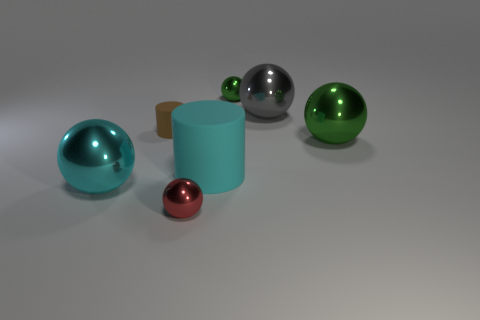What is the size of the metal object that is the same color as the big cylinder?
Give a very brief answer. Large. Do the brown thing and the cyan matte cylinder have the same size?
Make the answer very short. No. What size is the object that is both in front of the big cylinder and to the left of the red object?
Ensure brevity in your answer.  Large. How many shiny things are cyan objects or large things?
Provide a succinct answer. 3. Are there more cyan objects that are to the right of the small red metallic object than large yellow rubber balls?
Make the answer very short. Yes. What is the material of the ball that is left of the red thing?
Offer a terse response. Metal. How many spheres are made of the same material as the large cyan cylinder?
Provide a short and direct response. 0. What shape is the large metal object that is both behind the big cyan sphere and left of the big green metal sphere?
Give a very brief answer. Sphere. How many objects are either things that are on the right side of the small green sphere or metallic objects left of the large cyan rubber cylinder?
Make the answer very short. 4. Are there an equal number of tiny red spheres behind the tiny rubber cylinder and large shiny spheres on the left side of the gray thing?
Keep it short and to the point. No. 